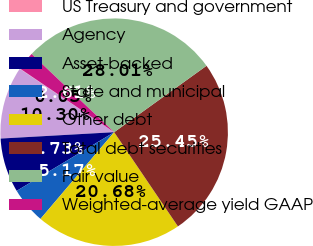Convert chart to OTSL. <chart><loc_0><loc_0><loc_500><loc_500><pie_chart><fcel>US Treasury and government<fcel>Agency<fcel>Asset-backed<fcel>State and municipal<fcel>Other debt<fcel>Total debt securities<fcel>Fair value<fcel>Weighted-average yield GAAP<nl><fcel>0.05%<fcel>10.3%<fcel>7.73%<fcel>5.17%<fcel>20.68%<fcel>25.45%<fcel>28.01%<fcel>2.61%<nl></chart> 